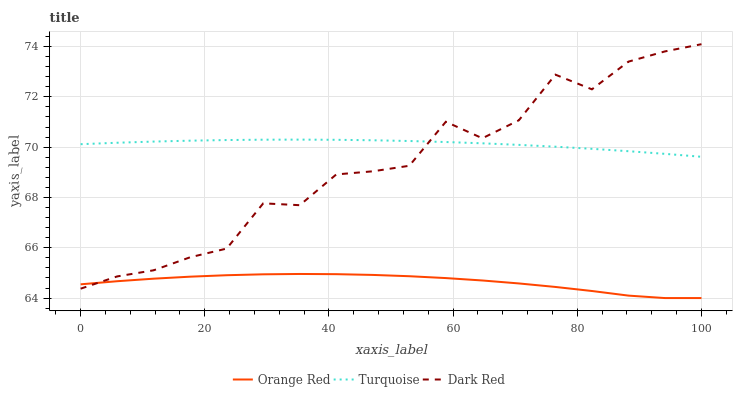Does Orange Red have the minimum area under the curve?
Answer yes or no. Yes. Does Turquoise have the maximum area under the curve?
Answer yes or no. Yes. Does Turquoise have the minimum area under the curve?
Answer yes or no. No. Does Orange Red have the maximum area under the curve?
Answer yes or no. No. Is Turquoise the smoothest?
Answer yes or no. Yes. Is Dark Red the roughest?
Answer yes or no. Yes. Is Orange Red the smoothest?
Answer yes or no. No. Is Orange Red the roughest?
Answer yes or no. No. Does Orange Red have the lowest value?
Answer yes or no. Yes. Does Turquoise have the lowest value?
Answer yes or no. No. Does Dark Red have the highest value?
Answer yes or no. Yes. Does Turquoise have the highest value?
Answer yes or no. No. Is Orange Red less than Turquoise?
Answer yes or no. Yes. Is Turquoise greater than Orange Red?
Answer yes or no. Yes. Does Orange Red intersect Dark Red?
Answer yes or no. Yes. Is Orange Red less than Dark Red?
Answer yes or no. No. Is Orange Red greater than Dark Red?
Answer yes or no. No. Does Orange Red intersect Turquoise?
Answer yes or no. No. 